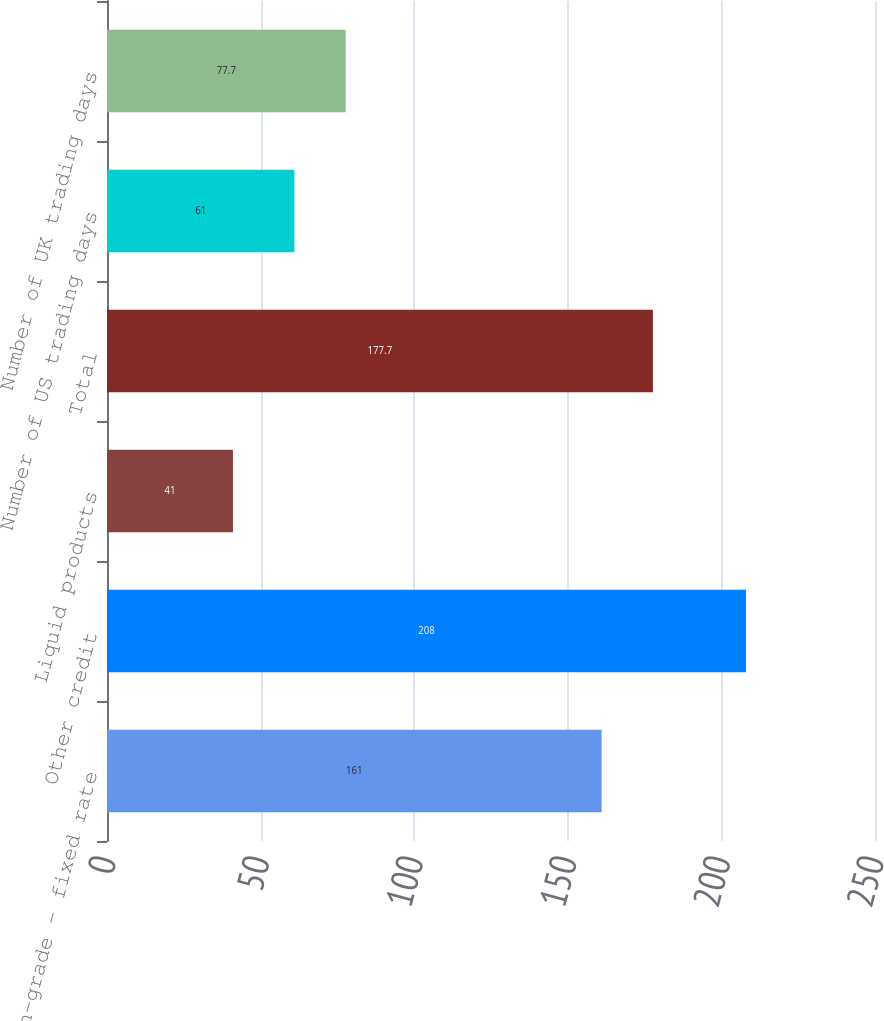Convert chart to OTSL. <chart><loc_0><loc_0><loc_500><loc_500><bar_chart><fcel>US high-grade - fixed rate<fcel>Other credit<fcel>Liquid products<fcel>Total<fcel>Number of US trading days<fcel>Number of UK trading days<nl><fcel>161<fcel>208<fcel>41<fcel>177.7<fcel>61<fcel>77.7<nl></chart> 